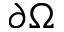<formula> <loc_0><loc_0><loc_500><loc_500>{ \partial \Omega }</formula> 